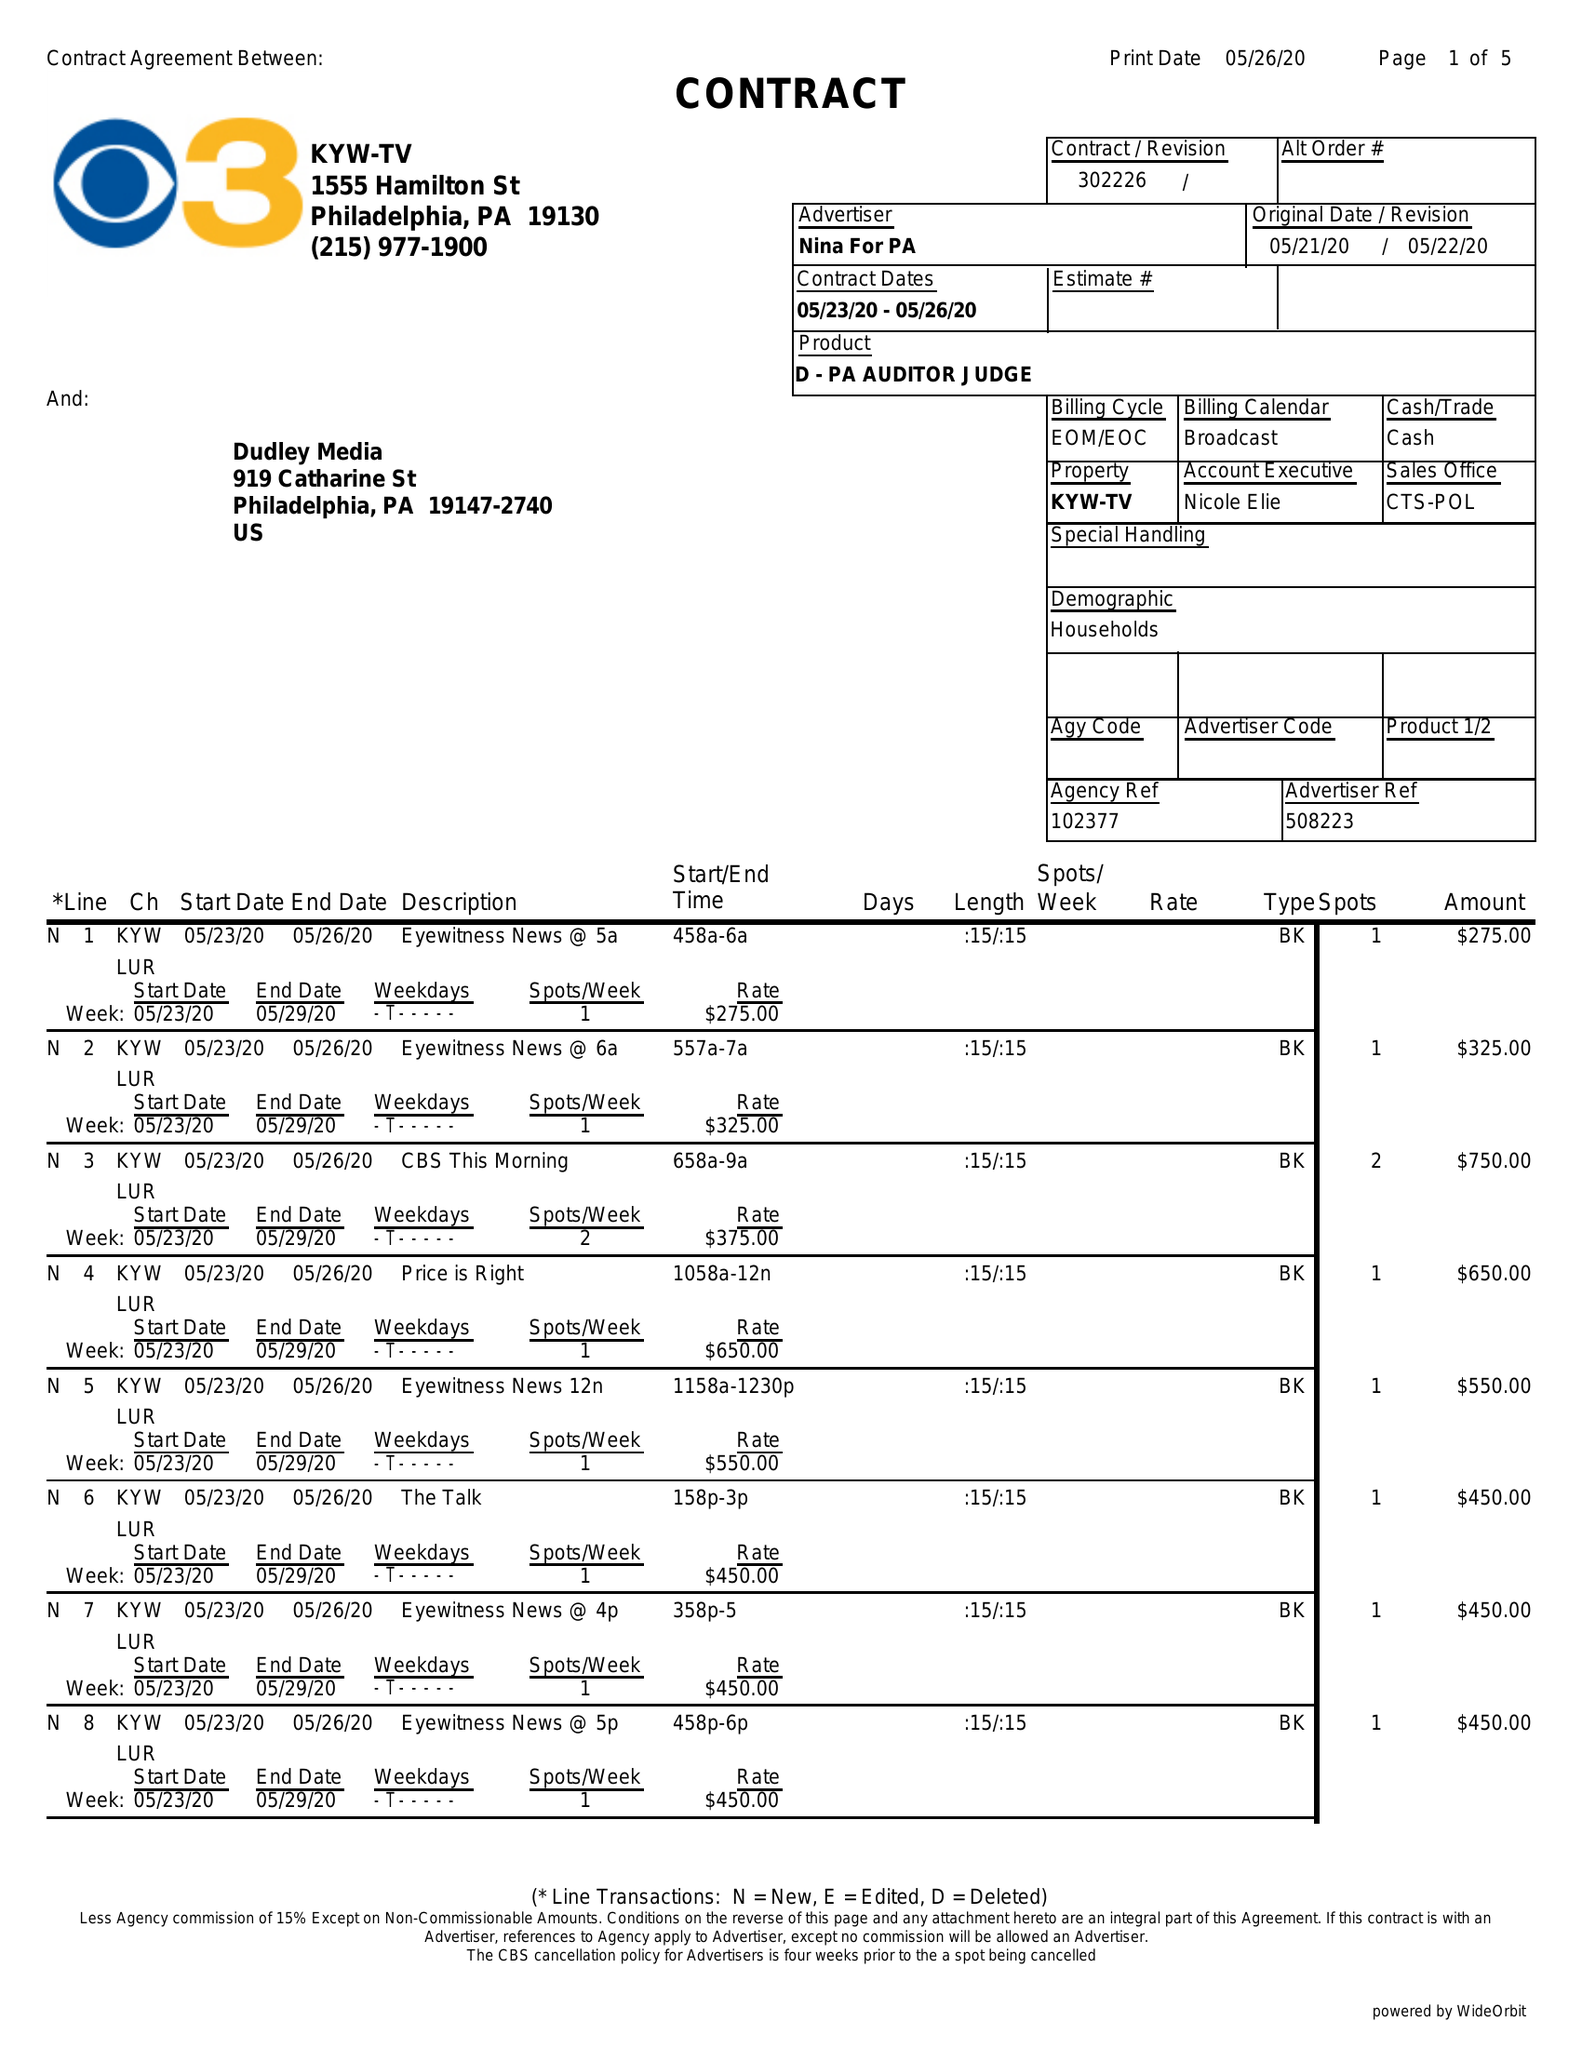What is the value for the flight_to?
Answer the question using a single word or phrase. 05/26/20 